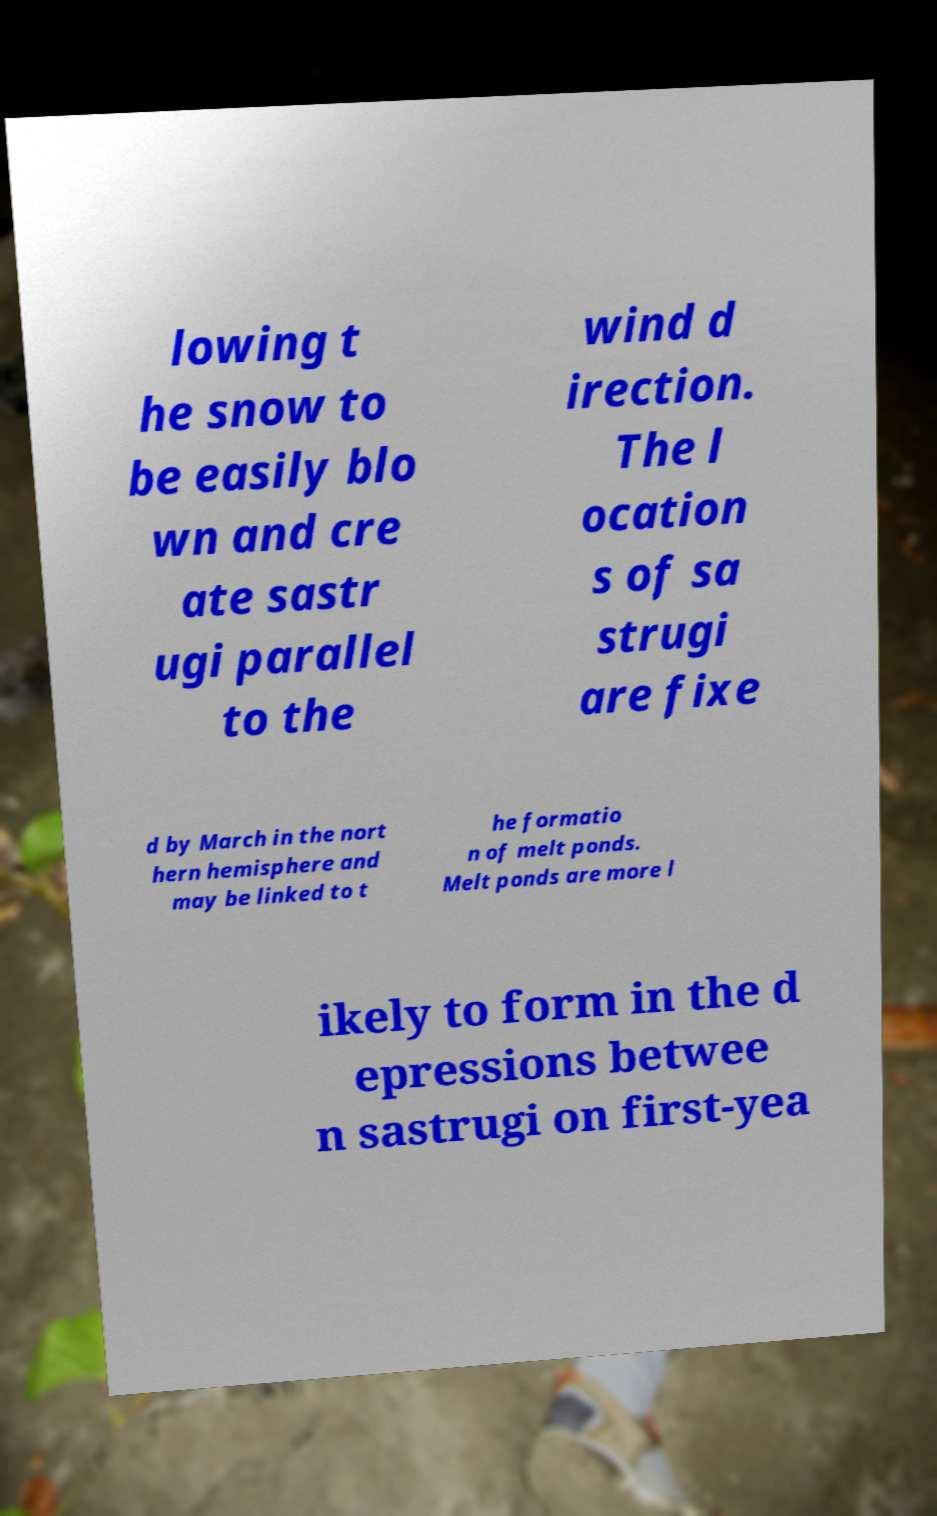What messages or text are displayed in this image? I need them in a readable, typed format. lowing t he snow to be easily blo wn and cre ate sastr ugi parallel to the wind d irection. The l ocation s of sa strugi are fixe d by March in the nort hern hemisphere and may be linked to t he formatio n of melt ponds. Melt ponds are more l ikely to form in the d epressions betwee n sastrugi on first-yea 